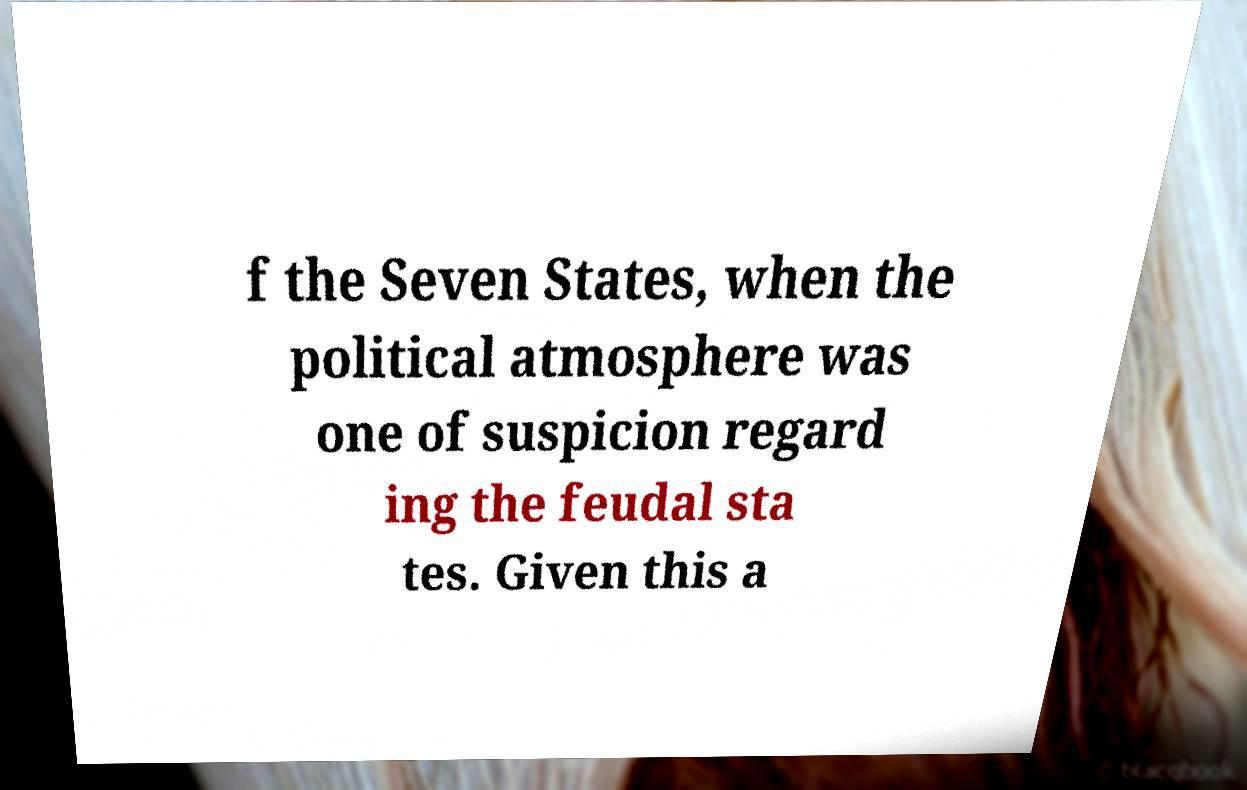Can you accurately transcribe the text from the provided image for me? f the Seven States, when the political atmosphere was one of suspicion regard ing the feudal sta tes. Given this a 